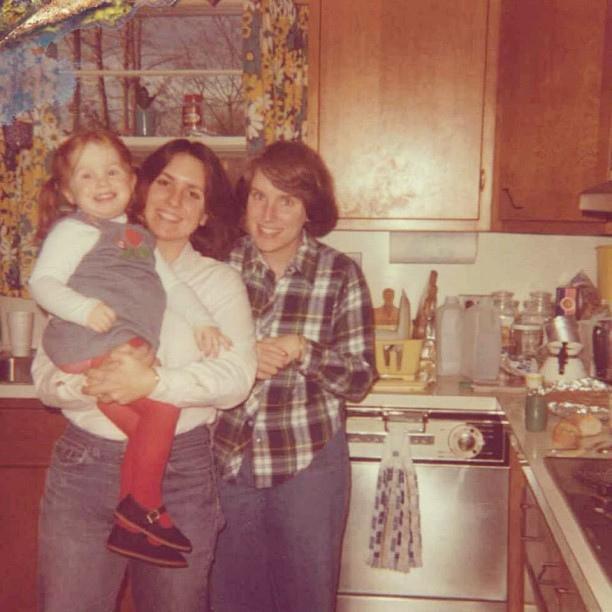How many bottles are there?
Give a very brief answer. 2. How many people are there?
Give a very brief answer. 3. 